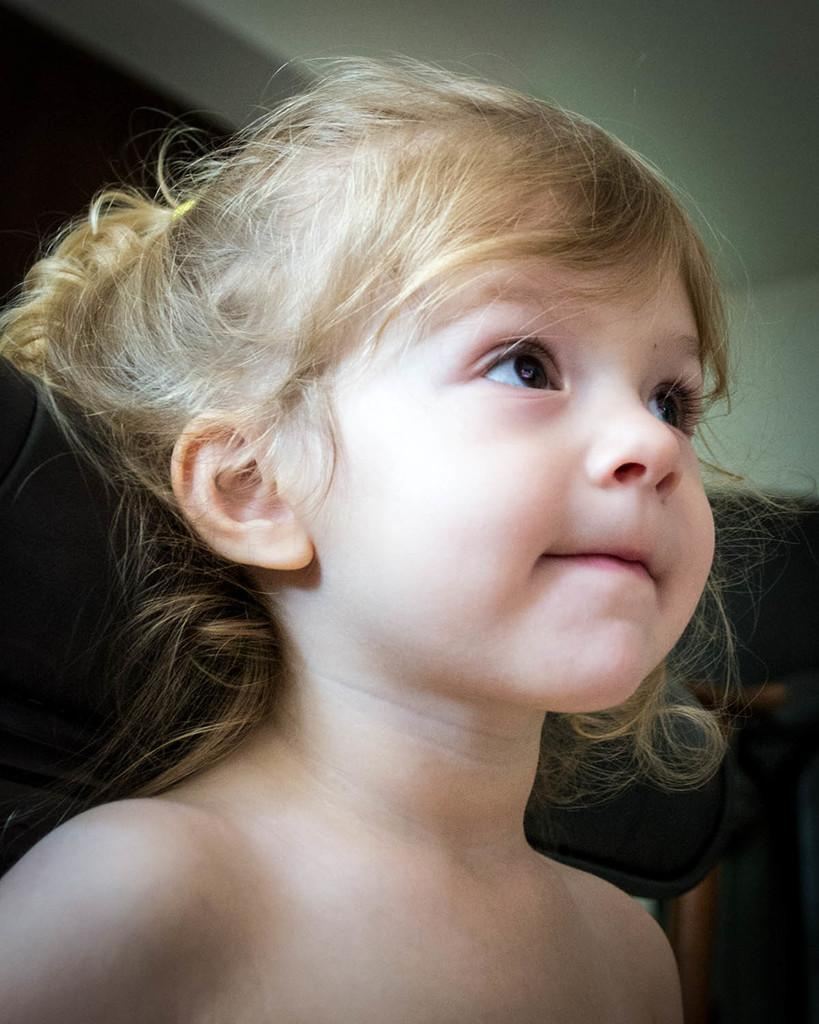What is the main subject of the image? There is a child in the image. How many pies does the child have in the image? There is no information about pies in the image, as the only fact provided is that there is a child in the image. What type of cabbage is the child holding in the image? There is no cabbage present in the image, as the only fact provided is that there is a child in the image. 